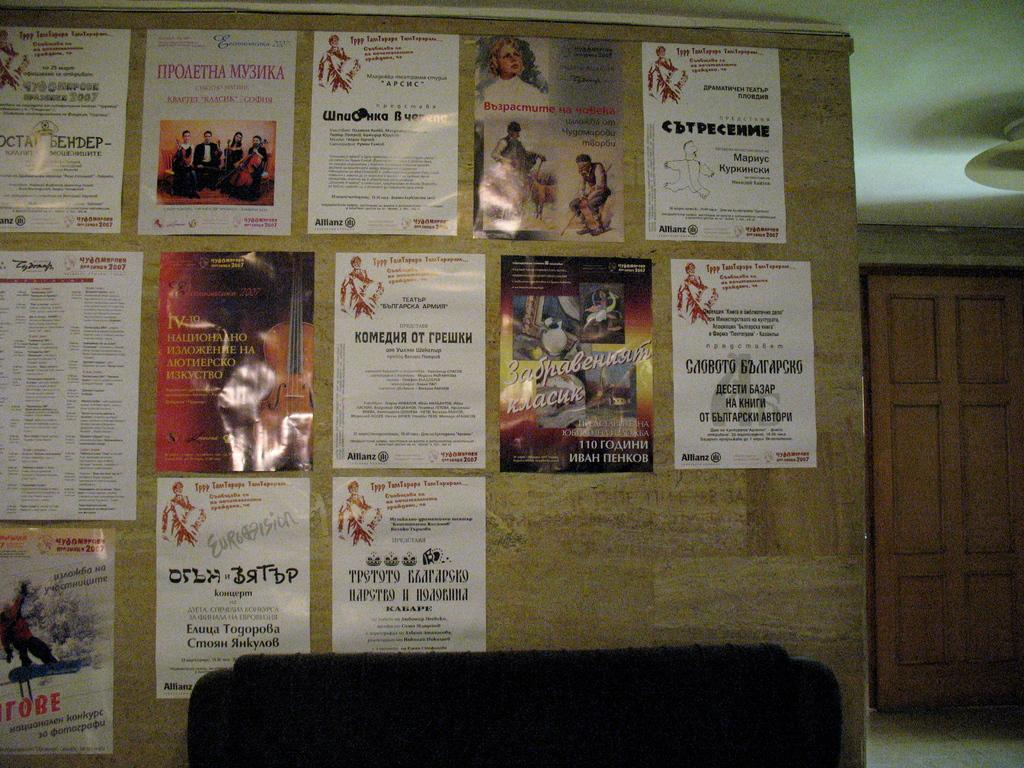Provide a one-sentence caption for the provided image. A flyer has a cello on it and the Roman numeral IV. 